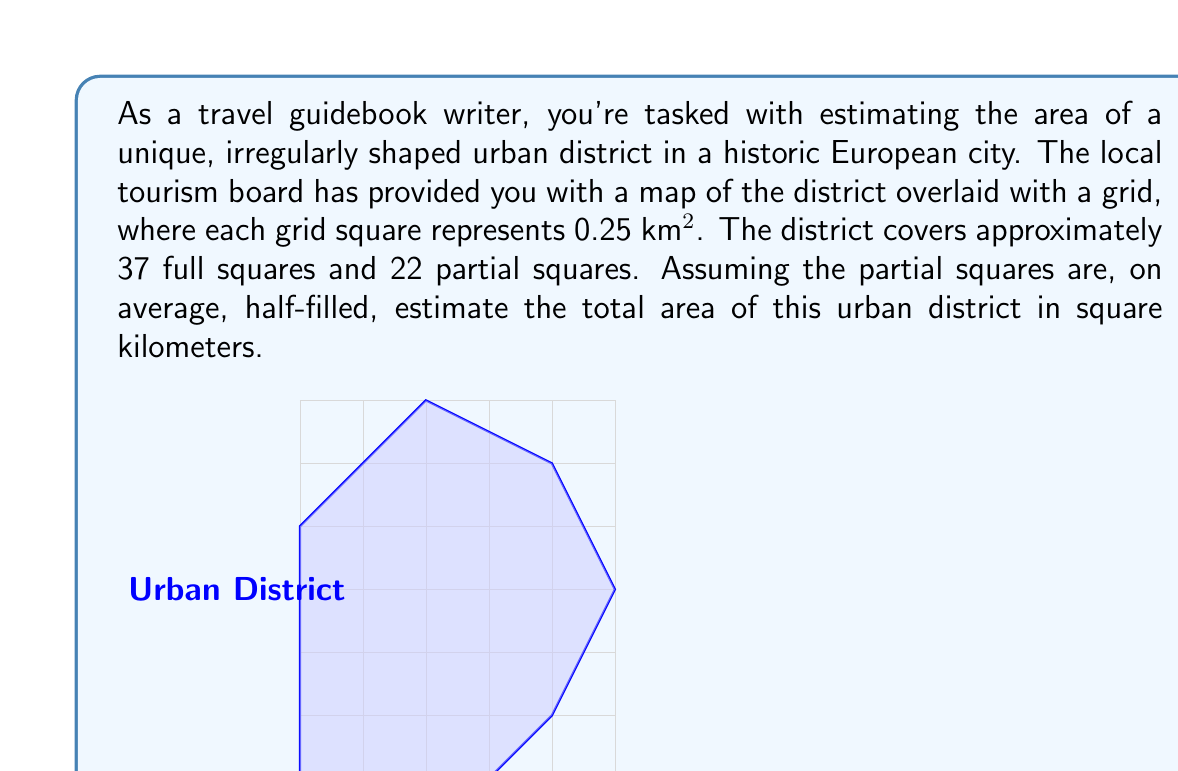Can you answer this question? To estimate the area of the irregularly shaped urban district, we'll follow these steps:

1) First, let's calculate the area covered by the full squares:
   $$ \text{Area of full squares} = 37 \times 0.25 \text{ km}^2 = 9.25 \text{ km}^2 $$

2) Now, we need to account for the partial squares. We're told that there are 22 partial squares and that they are, on average, half-filled. This means we can treat them as 11 full squares:
   $$ \text{Equivalent full squares from partials} = 22 \times 0.5 = 11 $$

3) Calculate the area of these equivalent full squares:
   $$ \text{Area of partial squares} = 11 \times 0.25 \text{ km}^2 = 2.75 \text{ km}^2 $$

4) To get the total estimated area, we sum the areas from steps 1 and 3:
   $$ \text{Total estimated area} = 9.25 \text{ km}^2 + 2.75 \text{ km}^2 = 12 \text{ km}^2 $$

Therefore, the estimated area of the urban district is 12 square kilometers.
Answer: $12 \text{ km}^2$ 